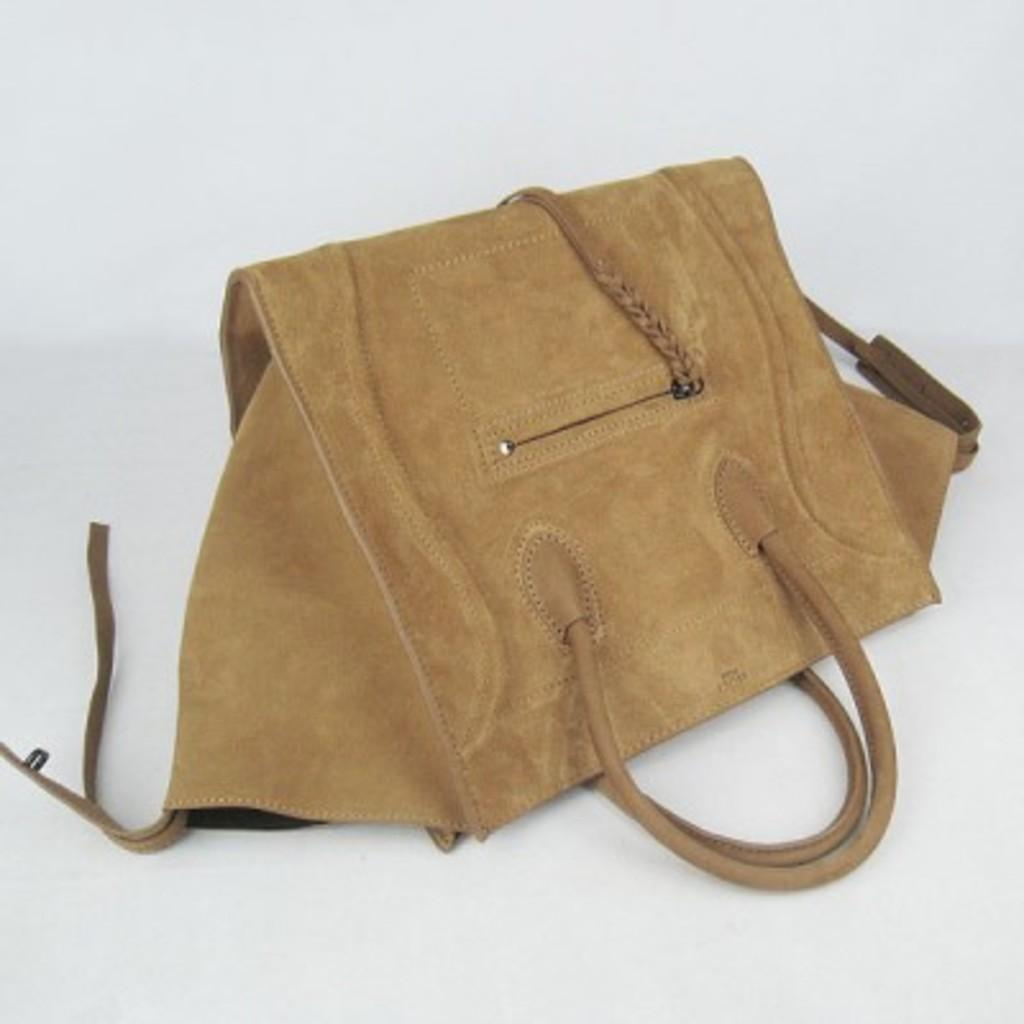What object can be seen in the image? There is a handbag in the image. What is the color of the handbag? The handbag is brown in color. How many vans are parked next to the handbag in the image? There are no vans present in the image; it only features a brown handbag. 